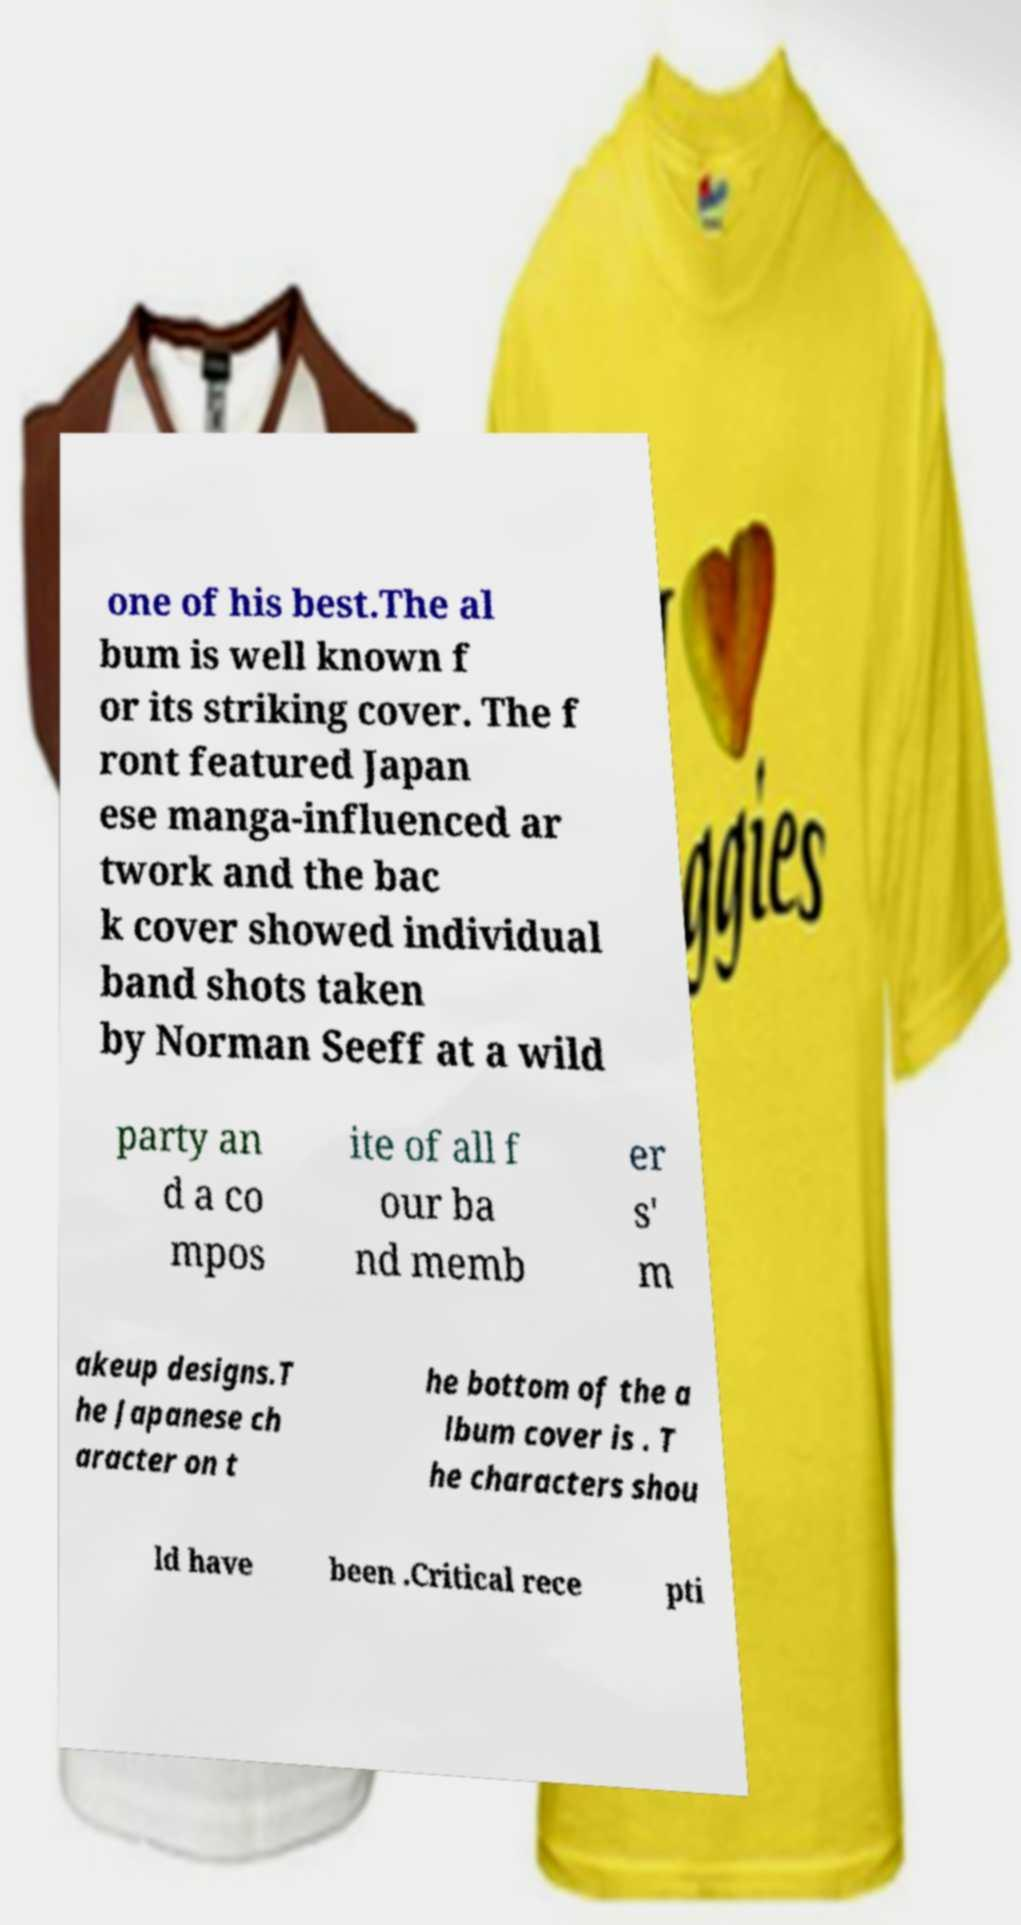For documentation purposes, I need the text within this image transcribed. Could you provide that? one of his best.The al bum is well known f or its striking cover. The f ront featured Japan ese manga-influenced ar twork and the bac k cover showed individual band shots taken by Norman Seeff at a wild party an d a co mpos ite of all f our ba nd memb er s' m akeup designs.T he Japanese ch aracter on t he bottom of the a lbum cover is . T he characters shou ld have been .Critical rece pti 